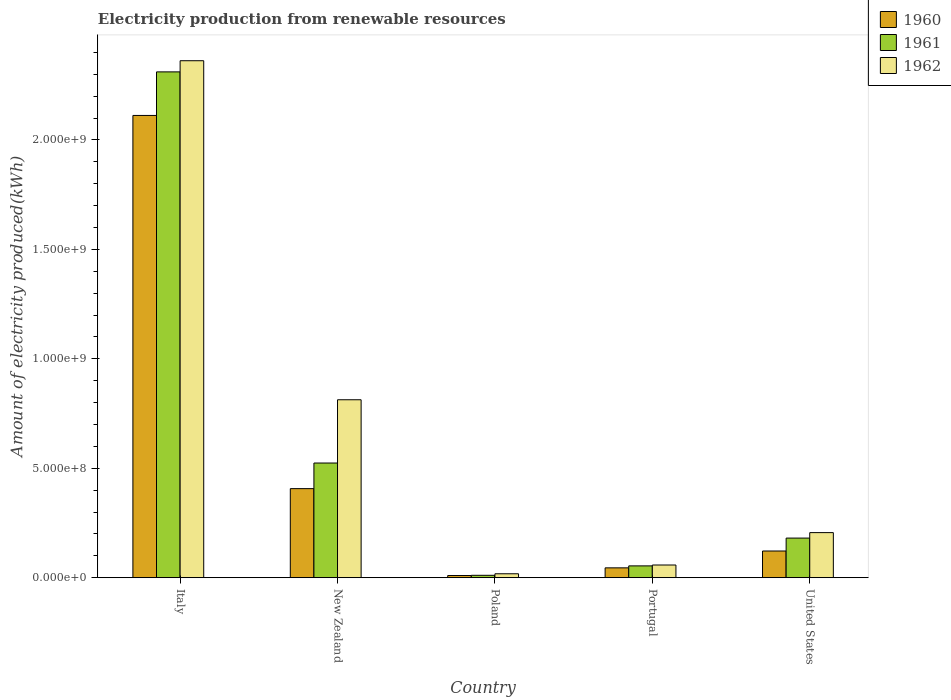How many groups of bars are there?
Offer a terse response. 5. How many bars are there on the 1st tick from the left?
Keep it short and to the point. 3. What is the amount of electricity produced in 1960 in New Zealand?
Your answer should be compact. 4.07e+08. Across all countries, what is the maximum amount of electricity produced in 1962?
Ensure brevity in your answer.  2.36e+09. In which country was the amount of electricity produced in 1960 maximum?
Provide a short and direct response. Italy. In which country was the amount of electricity produced in 1962 minimum?
Your answer should be compact. Poland. What is the total amount of electricity produced in 1962 in the graph?
Offer a terse response. 3.46e+09. What is the difference between the amount of electricity produced in 1961 in Italy and that in New Zealand?
Provide a short and direct response. 1.79e+09. What is the difference between the amount of electricity produced in 1960 in United States and the amount of electricity produced in 1961 in Italy?
Your answer should be compact. -2.19e+09. What is the average amount of electricity produced in 1960 per country?
Make the answer very short. 5.39e+08. What is the difference between the amount of electricity produced of/in 1960 and amount of electricity produced of/in 1962 in Portugal?
Keep it short and to the point. -1.30e+07. In how many countries, is the amount of electricity produced in 1961 greater than 900000000 kWh?
Give a very brief answer. 1. What is the ratio of the amount of electricity produced in 1961 in Portugal to that in United States?
Offer a very short reply. 0.3. Is the amount of electricity produced in 1961 in Poland less than that in United States?
Provide a succinct answer. Yes. What is the difference between the highest and the second highest amount of electricity produced in 1961?
Your response must be concise. 1.79e+09. What is the difference between the highest and the lowest amount of electricity produced in 1961?
Your answer should be very brief. 2.30e+09. In how many countries, is the amount of electricity produced in 1960 greater than the average amount of electricity produced in 1960 taken over all countries?
Make the answer very short. 1. Is the sum of the amount of electricity produced in 1962 in New Zealand and Portugal greater than the maximum amount of electricity produced in 1961 across all countries?
Your answer should be very brief. No. Does the graph contain any zero values?
Offer a terse response. No. Where does the legend appear in the graph?
Provide a short and direct response. Top right. How many legend labels are there?
Keep it short and to the point. 3. How are the legend labels stacked?
Provide a succinct answer. Vertical. What is the title of the graph?
Offer a terse response. Electricity production from renewable resources. What is the label or title of the X-axis?
Offer a terse response. Country. What is the label or title of the Y-axis?
Your response must be concise. Amount of electricity produced(kWh). What is the Amount of electricity produced(kWh) in 1960 in Italy?
Your answer should be very brief. 2.11e+09. What is the Amount of electricity produced(kWh) of 1961 in Italy?
Offer a very short reply. 2.31e+09. What is the Amount of electricity produced(kWh) of 1962 in Italy?
Give a very brief answer. 2.36e+09. What is the Amount of electricity produced(kWh) of 1960 in New Zealand?
Offer a terse response. 4.07e+08. What is the Amount of electricity produced(kWh) in 1961 in New Zealand?
Provide a short and direct response. 5.24e+08. What is the Amount of electricity produced(kWh) of 1962 in New Zealand?
Keep it short and to the point. 8.13e+08. What is the Amount of electricity produced(kWh) in 1960 in Poland?
Offer a terse response. 1.00e+07. What is the Amount of electricity produced(kWh) of 1961 in Poland?
Provide a short and direct response. 1.10e+07. What is the Amount of electricity produced(kWh) of 1962 in Poland?
Your answer should be very brief. 1.80e+07. What is the Amount of electricity produced(kWh) in 1960 in Portugal?
Make the answer very short. 4.50e+07. What is the Amount of electricity produced(kWh) of 1961 in Portugal?
Your answer should be very brief. 5.40e+07. What is the Amount of electricity produced(kWh) in 1962 in Portugal?
Provide a succinct answer. 5.80e+07. What is the Amount of electricity produced(kWh) in 1960 in United States?
Your response must be concise. 1.22e+08. What is the Amount of electricity produced(kWh) of 1961 in United States?
Provide a succinct answer. 1.81e+08. What is the Amount of electricity produced(kWh) of 1962 in United States?
Ensure brevity in your answer.  2.06e+08. Across all countries, what is the maximum Amount of electricity produced(kWh) of 1960?
Provide a succinct answer. 2.11e+09. Across all countries, what is the maximum Amount of electricity produced(kWh) of 1961?
Ensure brevity in your answer.  2.31e+09. Across all countries, what is the maximum Amount of electricity produced(kWh) of 1962?
Make the answer very short. 2.36e+09. Across all countries, what is the minimum Amount of electricity produced(kWh) in 1960?
Your response must be concise. 1.00e+07. Across all countries, what is the minimum Amount of electricity produced(kWh) in 1961?
Your response must be concise. 1.10e+07. Across all countries, what is the minimum Amount of electricity produced(kWh) of 1962?
Keep it short and to the point. 1.80e+07. What is the total Amount of electricity produced(kWh) in 1960 in the graph?
Provide a succinct answer. 2.70e+09. What is the total Amount of electricity produced(kWh) of 1961 in the graph?
Ensure brevity in your answer.  3.08e+09. What is the total Amount of electricity produced(kWh) in 1962 in the graph?
Provide a short and direct response. 3.46e+09. What is the difference between the Amount of electricity produced(kWh) of 1960 in Italy and that in New Zealand?
Your answer should be compact. 1.70e+09. What is the difference between the Amount of electricity produced(kWh) of 1961 in Italy and that in New Zealand?
Give a very brief answer. 1.79e+09. What is the difference between the Amount of electricity produced(kWh) of 1962 in Italy and that in New Zealand?
Make the answer very short. 1.55e+09. What is the difference between the Amount of electricity produced(kWh) of 1960 in Italy and that in Poland?
Ensure brevity in your answer.  2.10e+09. What is the difference between the Amount of electricity produced(kWh) of 1961 in Italy and that in Poland?
Provide a short and direct response. 2.30e+09. What is the difference between the Amount of electricity produced(kWh) in 1962 in Italy and that in Poland?
Your answer should be very brief. 2.34e+09. What is the difference between the Amount of electricity produced(kWh) in 1960 in Italy and that in Portugal?
Your answer should be compact. 2.07e+09. What is the difference between the Amount of electricity produced(kWh) of 1961 in Italy and that in Portugal?
Provide a short and direct response. 2.26e+09. What is the difference between the Amount of electricity produced(kWh) in 1962 in Italy and that in Portugal?
Keep it short and to the point. 2.30e+09. What is the difference between the Amount of electricity produced(kWh) in 1960 in Italy and that in United States?
Give a very brief answer. 1.99e+09. What is the difference between the Amount of electricity produced(kWh) in 1961 in Italy and that in United States?
Keep it short and to the point. 2.13e+09. What is the difference between the Amount of electricity produced(kWh) in 1962 in Italy and that in United States?
Your response must be concise. 2.16e+09. What is the difference between the Amount of electricity produced(kWh) of 1960 in New Zealand and that in Poland?
Give a very brief answer. 3.97e+08. What is the difference between the Amount of electricity produced(kWh) in 1961 in New Zealand and that in Poland?
Keep it short and to the point. 5.13e+08. What is the difference between the Amount of electricity produced(kWh) of 1962 in New Zealand and that in Poland?
Offer a very short reply. 7.95e+08. What is the difference between the Amount of electricity produced(kWh) in 1960 in New Zealand and that in Portugal?
Keep it short and to the point. 3.62e+08. What is the difference between the Amount of electricity produced(kWh) in 1961 in New Zealand and that in Portugal?
Keep it short and to the point. 4.70e+08. What is the difference between the Amount of electricity produced(kWh) of 1962 in New Zealand and that in Portugal?
Offer a very short reply. 7.55e+08. What is the difference between the Amount of electricity produced(kWh) of 1960 in New Zealand and that in United States?
Make the answer very short. 2.85e+08. What is the difference between the Amount of electricity produced(kWh) of 1961 in New Zealand and that in United States?
Your answer should be very brief. 3.43e+08. What is the difference between the Amount of electricity produced(kWh) of 1962 in New Zealand and that in United States?
Make the answer very short. 6.07e+08. What is the difference between the Amount of electricity produced(kWh) in 1960 in Poland and that in Portugal?
Your response must be concise. -3.50e+07. What is the difference between the Amount of electricity produced(kWh) in 1961 in Poland and that in Portugal?
Provide a succinct answer. -4.30e+07. What is the difference between the Amount of electricity produced(kWh) in 1962 in Poland and that in Portugal?
Offer a terse response. -4.00e+07. What is the difference between the Amount of electricity produced(kWh) of 1960 in Poland and that in United States?
Provide a short and direct response. -1.12e+08. What is the difference between the Amount of electricity produced(kWh) of 1961 in Poland and that in United States?
Your answer should be compact. -1.70e+08. What is the difference between the Amount of electricity produced(kWh) of 1962 in Poland and that in United States?
Your answer should be compact. -1.88e+08. What is the difference between the Amount of electricity produced(kWh) of 1960 in Portugal and that in United States?
Provide a succinct answer. -7.70e+07. What is the difference between the Amount of electricity produced(kWh) of 1961 in Portugal and that in United States?
Give a very brief answer. -1.27e+08. What is the difference between the Amount of electricity produced(kWh) in 1962 in Portugal and that in United States?
Provide a succinct answer. -1.48e+08. What is the difference between the Amount of electricity produced(kWh) in 1960 in Italy and the Amount of electricity produced(kWh) in 1961 in New Zealand?
Offer a very short reply. 1.59e+09. What is the difference between the Amount of electricity produced(kWh) in 1960 in Italy and the Amount of electricity produced(kWh) in 1962 in New Zealand?
Your answer should be compact. 1.30e+09. What is the difference between the Amount of electricity produced(kWh) of 1961 in Italy and the Amount of electricity produced(kWh) of 1962 in New Zealand?
Offer a very short reply. 1.50e+09. What is the difference between the Amount of electricity produced(kWh) in 1960 in Italy and the Amount of electricity produced(kWh) in 1961 in Poland?
Offer a very short reply. 2.10e+09. What is the difference between the Amount of electricity produced(kWh) in 1960 in Italy and the Amount of electricity produced(kWh) in 1962 in Poland?
Offer a terse response. 2.09e+09. What is the difference between the Amount of electricity produced(kWh) of 1961 in Italy and the Amount of electricity produced(kWh) of 1962 in Poland?
Provide a short and direct response. 2.29e+09. What is the difference between the Amount of electricity produced(kWh) in 1960 in Italy and the Amount of electricity produced(kWh) in 1961 in Portugal?
Provide a short and direct response. 2.06e+09. What is the difference between the Amount of electricity produced(kWh) of 1960 in Italy and the Amount of electricity produced(kWh) of 1962 in Portugal?
Offer a terse response. 2.05e+09. What is the difference between the Amount of electricity produced(kWh) of 1961 in Italy and the Amount of electricity produced(kWh) of 1962 in Portugal?
Your answer should be very brief. 2.25e+09. What is the difference between the Amount of electricity produced(kWh) in 1960 in Italy and the Amount of electricity produced(kWh) in 1961 in United States?
Provide a short and direct response. 1.93e+09. What is the difference between the Amount of electricity produced(kWh) of 1960 in Italy and the Amount of electricity produced(kWh) of 1962 in United States?
Offer a very short reply. 1.91e+09. What is the difference between the Amount of electricity produced(kWh) of 1961 in Italy and the Amount of electricity produced(kWh) of 1962 in United States?
Make the answer very short. 2.10e+09. What is the difference between the Amount of electricity produced(kWh) in 1960 in New Zealand and the Amount of electricity produced(kWh) in 1961 in Poland?
Provide a succinct answer. 3.96e+08. What is the difference between the Amount of electricity produced(kWh) in 1960 in New Zealand and the Amount of electricity produced(kWh) in 1962 in Poland?
Provide a succinct answer. 3.89e+08. What is the difference between the Amount of electricity produced(kWh) of 1961 in New Zealand and the Amount of electricity produced(kWh) of 1962 in Poland?
Offer a very short reply. 5.06e+08. What is the difference between the Amount of electricity produced(kWh) of 1960 in New Zealand and the Amount of electricity produced(kWh) of 1961 in Portugal?
Keep it short and to the point. 3.53e+08. What is the difference between the Amount of electricity produced(kWh) of 1960 in New Zealand and the Amount of electricity produced(kWh) of 1962 in Portugal?
Provide a succinct answer. 3.49e+08. What is the difference between the Amount of electricity produced(kWh) in 1961 in New Zealand and the Amount of electricity produced(kWh) in 1962 in Portugal?
Make the answer very short. 4.66e+08. What is the difference between the Amount of electricity produced(kWh) of 1960 in New Zealand and the Amount of electricity produced(kWh) of 1961 in United States?
Offer a very short reply. 2.26e+08. What is the difference between the Amount of electricity produced(kWh) in 1960 in New Zealand and the Amount of electricity produced(kWh) in 1962 in United States?
Provide a succinct answer. 2.01e+08. What is the difference between the Amount of electricity produced(kWh) in 1961 in New Zealand and the Amount of electricity produced(kWh) in 1962 in United States?
Your answer should be very brief. 3.18e+08. What is the difference between the Amount of electricity produced(kWh) in 1960 in Poland and the Amount of electricity produced(kWh) in 1961 in Portugal?
Keep it short and to the point. -4.40e+07. What is the difference between the Amount of electricity produced(kWh) in 1960 in Poland and the Amount of electricity produced(kWh) in 1962 in Portugal?
Your response must be concise. -4.80e+07. What is the difference between the Amount of electricity produced(kWh) in 1961 in Poland and the Amount of electricity produced(kWh) in 1962 in Portugal?
Keep it short and to the point. -4.70e+07. What is the difference between the Amount of electricity produced(kWh) of 1960 in Poland and the Amount of electricity produced(kWh) of 1961 in United States?
Your answer should be very brief. -1.71e+08. What is the difference between the Amount of electricity produced(kWh) of 1960 in Poland and the Amount of electricity produced(kWh) of 1962 in United States?
Keep it short and to the point. -1.96e+08. What is the difference between the Amount of electricity produced(kWh) of 1961 in Poland and the Amount of electricity produced(kWh) of 1962 in United States?
Your response must be concise. -1.95e+08. What is the difference between the Amount of electricity produced(kWh) of 1960 in Portugal and the Amount of electricity produced(kWh) of 1961 in United States?
Your answer should be very brief. -1.36e+08. What is the difference between the Amount of electricity produced(kWh) in 1960 in Portugal and the Amount of electricity produced(kWh) in 1962 in United States?
Provide a short and direct response. -1.61e+08. What is the difference between the Amount of electricity produced(kWh) in 1961 in Portugal and the Amount of electricity produced(kWh) in 1962 in United States?
Offer a very short reply. -1.52e+08. What is the average Amount of electricity produced(kWh) of 1960 per country?
Give a very brief answer. 5.39e+08. What is the average Amount of electricity produced(kWh) of 1961 per country?
Provide a succinct answer. 6.16e+08. What is the average Amount of electricity produced(kWh) of 1962 per country?
Give a very brief answer. 6.91e+08. What is the difference between the Amount of electricity produced(kWh) in 1960 and Amount of electricity produced(kWh) in 1961 in Italy?
Offer a terse response. -1.99e+08. What is the difference between the Amount of electricity produced(kWh) of 1960 and Amount of electricity produced(kWh) of 1962 in Italy?
Ensure brevity in your answer.  -2.50e+08. What is the difference between the Amount of electricity produced(kWh) in 1961 and Amount of electricity produced(kWh) in 1962 in Italy?
Keep it short and to the point. -5.10e+07. What is the difference between the Amount of electricity produced(kWh) in 1960 and Amount of electricity produced(kWh) in 1961 in New Zealand?
Your response must be concise. -1.17e+08. What is the difference between the Amount of electricity produced(kWh) of 1960 and Amount of electricity produced(kWh) of 1962 in New Zealand?
Your response must be concise. -4.06e+08. What is the difference between the Amount of electricity produced(kWh) in 1961 and Amount of electricity produced(kWh) in 1962 in New Zealand?
Offer a very short reply. -2.89e+08. What is the difference between the Amount of electricity produced(kWh) of 1960 and Amount of electricity produced(kWh) of 1962 in Poland?
Ensure brevity in your answer.  -8.00e+06. What is the difference between the Amount of electricity produced(kWh) in 1961 and Amount of electricity produced(kWh) in 1962 in Poland?
Keep it short and to the point. -7.00e+06. What is the difference between the Amount of electricity produced(kWh) of 1960 and Amount of electricity produced(kWh) of 1961 in Portugal?
Give a very brief answer. -9.00e+06. What is the difference between the Amount of electricity produced(kWh) of 1960 and Amount of electricity produced(kWh) of 1962 in Portugal?
Give a very brief answer. -1.30e+07. What is the difference between the Amount of electricity produced(kWh) in 1960 and Amount of electricity produced(kWh) in 1961 in United States?
Make the answer very short. -5.90e+07. What is the difference between the Amount of electricity produced(kWh) of 1960 and Amount of electricity produced(kWh) of 1962 in United States?
Keep it short and to the point. -8.40e+07. What is the difference between the Amount of electricity produced(kWh) of 1961 and Amount of electricity produced(kWh) of 1962 in United States?
Offer a very short reply. -2.50e+07. What is the ratio of the Amount of electricity produced(kWh) in 1960 in Italy to that in New Zealand?
Offer a terse response. 5.19. What is the ratio of the Amount of electricity produced(kWh) in 1961 in Italy to that in New Zealand?
Offer a very short reply. 4.41. What is the ratio of the Amount of electricity produced(kWh) of 1962 in Italy to that in New Zealand?
Keep it short and to the point. 2.91. What is the ratio of the Amount of electricity produced(kWh) in 1960 in Italy to that in Poland?
Offer a terse response. 211.2. What is the ratio of the Amount of electricity produced(kWh) of 1961 in Italy to that in Poland?
Provide a succinct answer. 210.09. What is the ratio of the Amount of electricity produced(kWh) in 1962 in Italy to that in Poland?
Offer a terse response. 131.22. What is the ratio of the Amount of electricity produced(kWh) in 1960 in Italy to that in Portugal?
Keep it short and to the point. 46.93. What is the ratio of the Amount of electricity produced(kWh) of 1961 in Italy to that in Portugal?
Provide a succinct answer. 42.8. What is the ratio of the Amount of electricity produced(kWh) of 1962 in Italy to that in Portugal?
Ensure brevity in your answer.  40.72. What is the ratio of the Amount of electricity produced(kWh) in 1960 in Italy to that in United States?
Keep it short and to the point. 17.31. What is the ratio of the Amount of electricity produced(kWh) of 1961 in Italy to that in United States?
Your answer should be very brief. 12.77. What is the ratio of the Amount of electricity produced(kWh) in 1962 in Italy to that in United States?
Keep it short and to the point. 11.47. What is the ratio of the Amount of electricity produced(kWh) in 1960 in New Zealand to that in Poland?
Provide a short and direct response. 40.7. What is the ratio of the Amount of electricity produced(kWh) of 1961 in New Zealand to that in Poland?
Your answer should be very brief. 47.64. What is the ratio of the Amount of electricity produced(kWh) of 1962 in New Zealand to that in Poland?
Your answer should be compact. 45.17. What is the ratio of the Amount of electricity produced(kWh) in 1960 in New Zealand to that in Portugal?
Offer a terse response. 9.04. What is the ratio of the Amount of electricity produced(kWh) of 1961 in New Zealand to that in Portugal?
Make the answer very short. 9.7. What is the ratio of the Amount of electricity produced(kWh) in 1962 in New Zealand to that in Portugal?
Ensure brevity in your answer.  14.02. What is the ratio of the Amount of electricity produced(kWh) of 1960 in New Zealand to that in United States?
Offer a very short reply. 3.34. What is the ratio of the Amount of electricity produced(kWh) of 1961 in New Zealand to that in United States?
Provide a short and direct response. 2.9. What is the ratio of the Amount of electricity produced(kWh) in 1962 in New Zealand to that in United States?
Your response must be concise. 3.95. What is the ratio of the Amount of electricity produced(kWh) of 1960 in Poland to that in Portugal?
Offer a very short reply. 0.22. What is the ratio of the Amount of electricity produced(kWh) of 1961 in Poland to that in Portugal?
Provide a succinct answer. 0.2. What is the ratio of the Amount of electricity produced(kWh) of 1962 in Poland to that in Portugal?
Ensure brevity in your answer.  0.31. What is the ratio of the Amount of electricity produced(kWh) of 1960 in Poland to that in United States?
Ensure brevity in your answer.  0.08. What is the ratio of the Amount of electricity produced(kWh) of 1961 in Poland to that in United States?
Give a very brief answer. 0.06. What is the ratio of the Amount of electricity produced(kWh) of 1962 in Poland to that in United States?
Offer a very short reply. 0.09. What is the ratio of the Amount of electricity produced(kWh) of 1960 in Portugal to that in United States?
Offer a terse response. 0.37. What is the ratio of the Amount of electricity produced(kWh) in 1961 in Portugal to that in United States?
Ensure brevity in your answer.  0.3. What is the ratio of the Amount of electricity produced(kWh) in 1962 in Portugal to that in United States?
Your response must be concise. 0.28. What is the difference between the highest and the second highest Amount of electricity produced(kWh) in 1960?
Your answer should be compact. 1.70e+09. What is the difference between the highest and the second highest Amount of electricity produced(kWh) in 1961?
Your answer should be very brief. 1.79e+09. What is the difference between the highest and the second highest Amount of electricity produced(kWh) in 1962?
Your response must be concise. 1.55e+09. What is the difference between the highest and the lowest Amount of electricity produced(kWh) in 1960?
Ensure brevity in your answer.  2.10e+09. What is the difference between the highest and the lowest Amount of electricity produced(kWh) in 1961?
Give a very brief answer. 2.30e+09. What is the difference between the highest and the lowest Amount of electricity produced(kWh) in 1962?
Provide a succinct answer. 2.34e+09. 